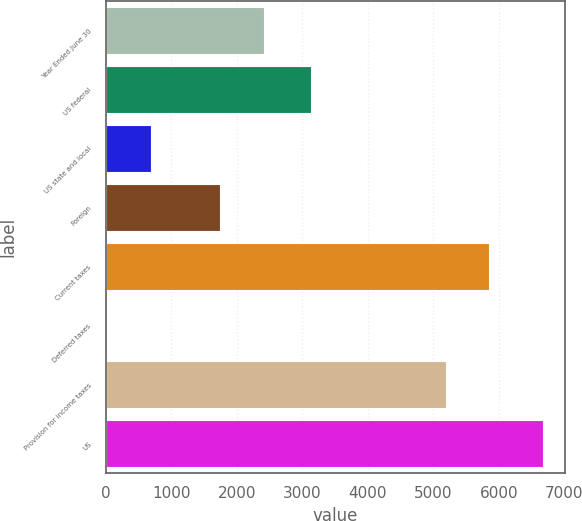Convert chart. <chart><loc_0><loc_0><loc_500><loc_500><bar_chart><fcel>Year Ended June 30<fcel>US federal<fcel>US state and local<fcel>Foreign<fcel>Current taxes<fcel>Deferred taxes<fcel>Provision for income taxes<fcel>US<nl><fcel>2410.5<fcel>3131<fcel>684.5<fcel>1745<fcel>5854.5<fcel>19<fcel>5189<fcel>6674<nl></chart> 